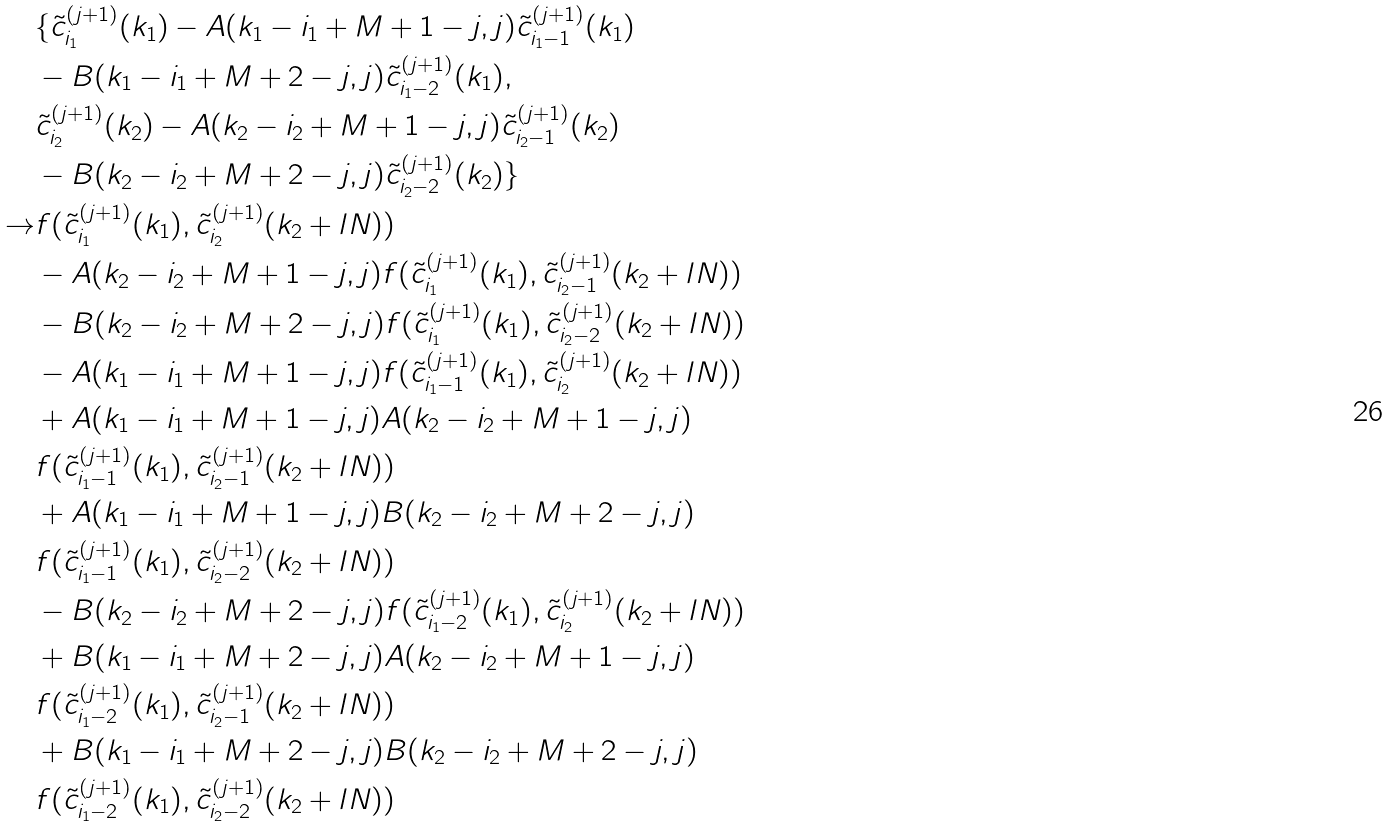Convert formula to latex. <formula><loc_0><loc_0><loc_500><loc_500>& \{ \tilde { c } ^ { ( j + 1 ) } _ { i _ { 1 } } ( k _ { 1 } ) - A ( k _ { 1 } - i _ { 1 } + M + 1 - j , j ) \tilde { c } ^ { ( j + 1 ) } _ { i _ { 1 } - 1 } ( k _ { 1 } ) \\ & - B ( k _ { 1 } - i _ { 1 } + M + 2 - j , j ) \tilde { c } ^ { ( j + 1 ) } _ { i _ { 1 } - 2 } ( k _ { 1 } ) , \\ & \tilde { c } ^ { ( j + 1 ) } _ { i _ { 2 } } ( k _ { 2 } ) - A ( k _ { 2 } - i _ { 2 } + M + 1 - j , j ) \tilde { c } ^ { ( j + 1 ) } _ { i _ { 2 } - 1 } ( k _ { 2 } ) \\ & - B ( k _ { 2 } - i _ { 2 } + M + 2 - j , j ) \tilde { c } ^ { ( j + 1 ) } _ { i _ { 2 } - 2 } ( k _ { 2 } ) \} \\ \rightarrow & f ( \tilde { c } _ { i _ { 1 } } ^ { ( j + 1 ) } ( k _ { 1 } ) , \tilde { c } _ { i _ { 2 } } ^ { ( j + 1 ) } ( k _ { 2 } + l N ) ) \\ & - A ( k _ { 2 } - i _ { 2 } + M + 1 - j , j ) f ( \tilde { c } _ { i _ { 1 } } ^ { ( j + 1 ) } ( k _ { 1 } ) , \tilde { c } _ { i _ { 2 } - 1 } ^ { ( j + 1 ) } ( k _ { 2 } + l N ) ) \\ & - B ( k _ { 2 } - i _ { 2 } + M + 2 - j , j ) f ( \tilde { c } _ { i _ { 1 } } ^ { ( j + 1 ) } ( k _ { 1 } ) , \tilde { c } _ { i _ { 2 } - 2 } ^ { ( j + 1 ) } ( k _ { 2 } + l N ) ) \\ & - A ( k _ { 1 } - i _ { 1 } + M + 1 - j , j ) f ( \tilde { c } _ { i _ { 1 } - 1 } ^ { ( j + 1 ) } ( k _ { 1 } ) , \tilde { c } _ { i _ { 2 } } ^ { ( j + 1 ) } ( k _ { 2 } + l N ) ) \\ & + A ( k _ { 1 } - i _ { 1 } + M + 1 - j , j ) A ( k _ { 2 } - i _ { 2 } + M + 1 - j , j ) \\ & f ( \tilde { c } _ { i _ { 1 } - 1 } ^ { ( j + 1 ) } ( k _ { 1 } ) , \tilde { c } _ { i _ { 2 } - 1 } ^ { ( j + 1 ) } ( k _ { 2 } + l N ) ) \\ & + A ( k _ { 1 } - i _ { 1 } + M + 1 - j , j ) B ( k _ { 2 } - i _ { 2 } + M + 2 - j , j ) \\ & f ( \tilde { c } _ { i _ { 1 } - 1 } ^ { ( j + 1 ) } ( k _ { 1 } ) , \tilde { c } _ { i _ { 2 } - 2 } ^ { ( j + 1 ) } ( k _ { 2 } + l N ) ) \\ & - B ( k _ { 2 } - i _ { 2 } + M + 2 - j , j ) f ( \tilde { c } _ { i _ { 1 } - 2 } ^ { ( j + 1 ) } ( k _ { 1 } ) , \tilde { c } _ { i _ { 2 } } ^ { ( j + 1 ) } ( k _ { 2 } + l N ) ) \\ & + B ( k _ { 1 } - i _ { 1 } + M + 2 - j , j ) A ( k _ { 2 } - i _ { 2 } + M + 1 - j , j ) \\ & f ( \tilde { c } _ { i _ { 1 } - 2 } ^ { ( j + 1 ) } ( k _ { 1 } ) , \tilde { c } _ { i _ { 2 } - 1 } ^ { ( j + 1 ) } ( k _ { 2 } + l N ) ) \\ & + B ( k _ { 1 } - i _ { 1 } + M + 2 - j , j ) B ( k _ { 2 } - i _ { 2 } + M + 2 - j , j ) \\ & f ( \tilde { c } _ { i _ { 1 } - 2 } ^ { ( j + 1 ) } ( k _ { 1 } ) , \tilde { c } _ { i _ { 2 } - 2 } ^ { ( j + 1 ) } ( k _ { 2 } + l N ) ) \\</formula> 